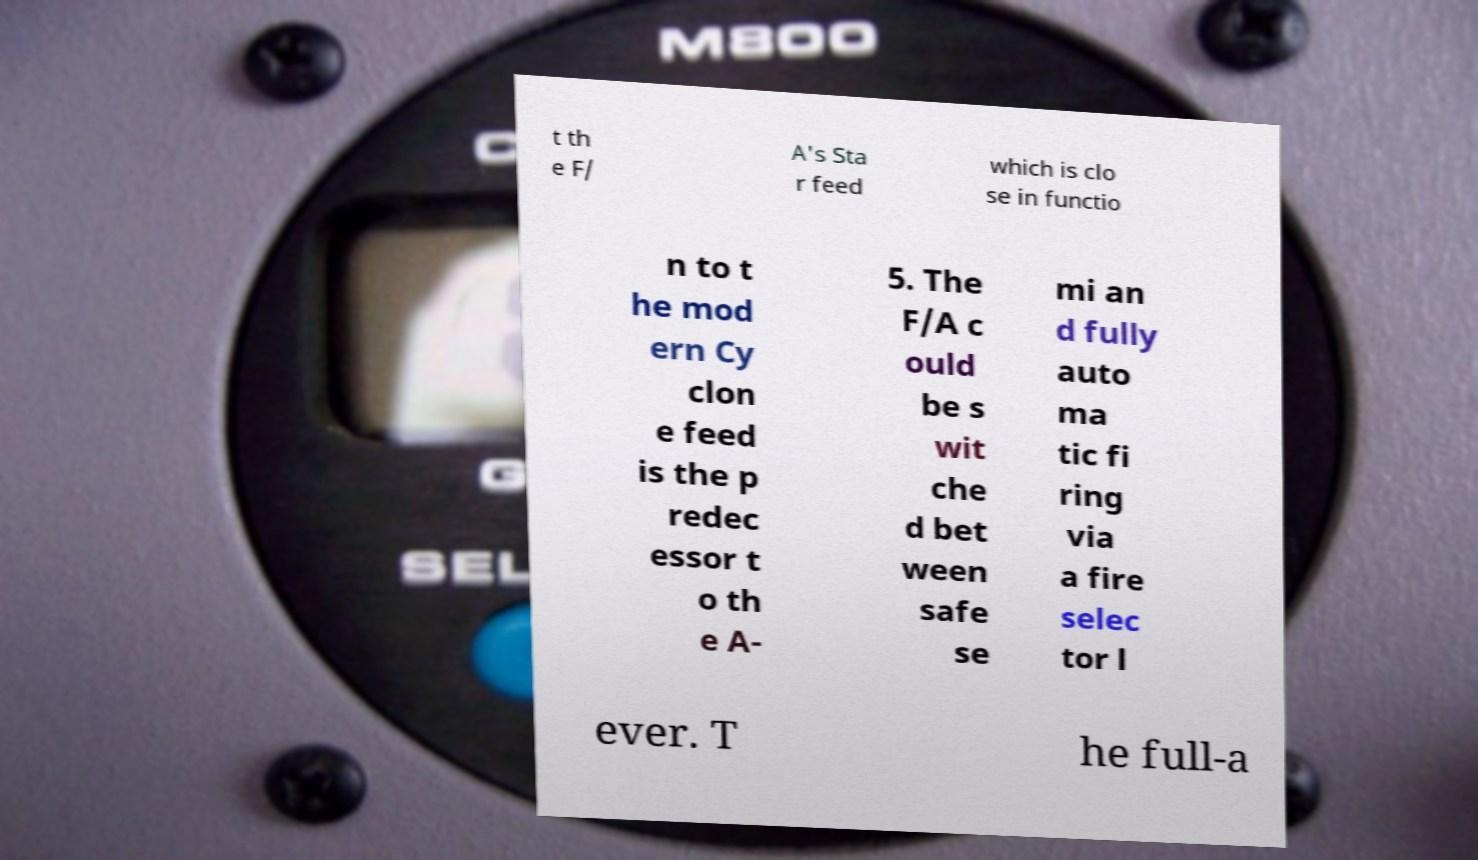Can you read and provide the text displayed in the image?This photo seems to have some interesting text. Can you extract and type it out for me? t th e F/ A's Sta r feed which is clo se in functio n to t he mod ern Cy clon e feed is the p redec essor t o th e A- 5. The F/A c ould be s wit che d bet ween safe se mi an d fully auto ma tic fi ring via a fire selec tor l ever. T he full-a 